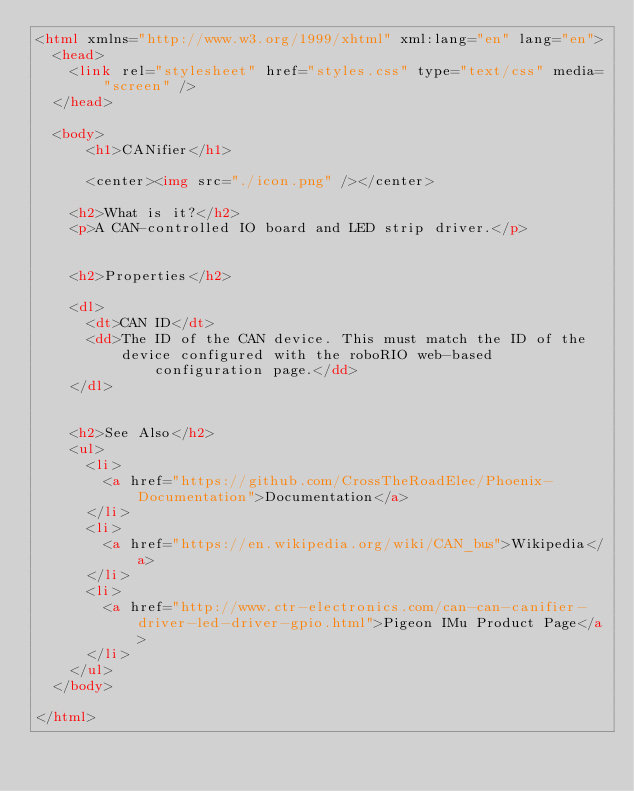Convert code to text. <code><loc_0><loc_0><loc_500><loc_500><_HTML_><html xmlns="http://www.w3.org/1999/xhtml" xml:lang="en" lang="en">
  <head>
    <link rel="stylesheet" href="styles.css" type="text/css" media="screen" />
  </head>

  <body>
      <h1>CANifier</h1>

      <center><img src="./icon.png" /></center>

    <h2>What is it?</h2>
    <p>A CAN-controlled IO board and LED strip driver.</p>


    <h2>Properties</h2>

    <dl>
      <dt>CAN ID</dt>
      <dd>The ID of the CAN device. This must match the ID of the
          device configured with the roboRIO web-based configuration page.</dd>
    </dl>


    <h2>See Also</h2>
    <ul>
	  <li>
        <a href="https://github.com/CrossTheRoadElec/Phoenix-Documentation">Documentation</a>
      </li>
      <li>
        <a href="https://en.wikipedia.org/wiki/CAN_bus">Wikipedia</a>
      </li>
      <li>
        <a href="http://www.ctr-electronics.com/can-can-canifier-driver-led-driver-gpio.html">Pigeon IMu Product Page</a>
      </li>
    </ul>
  </body>

</html>
</code> 